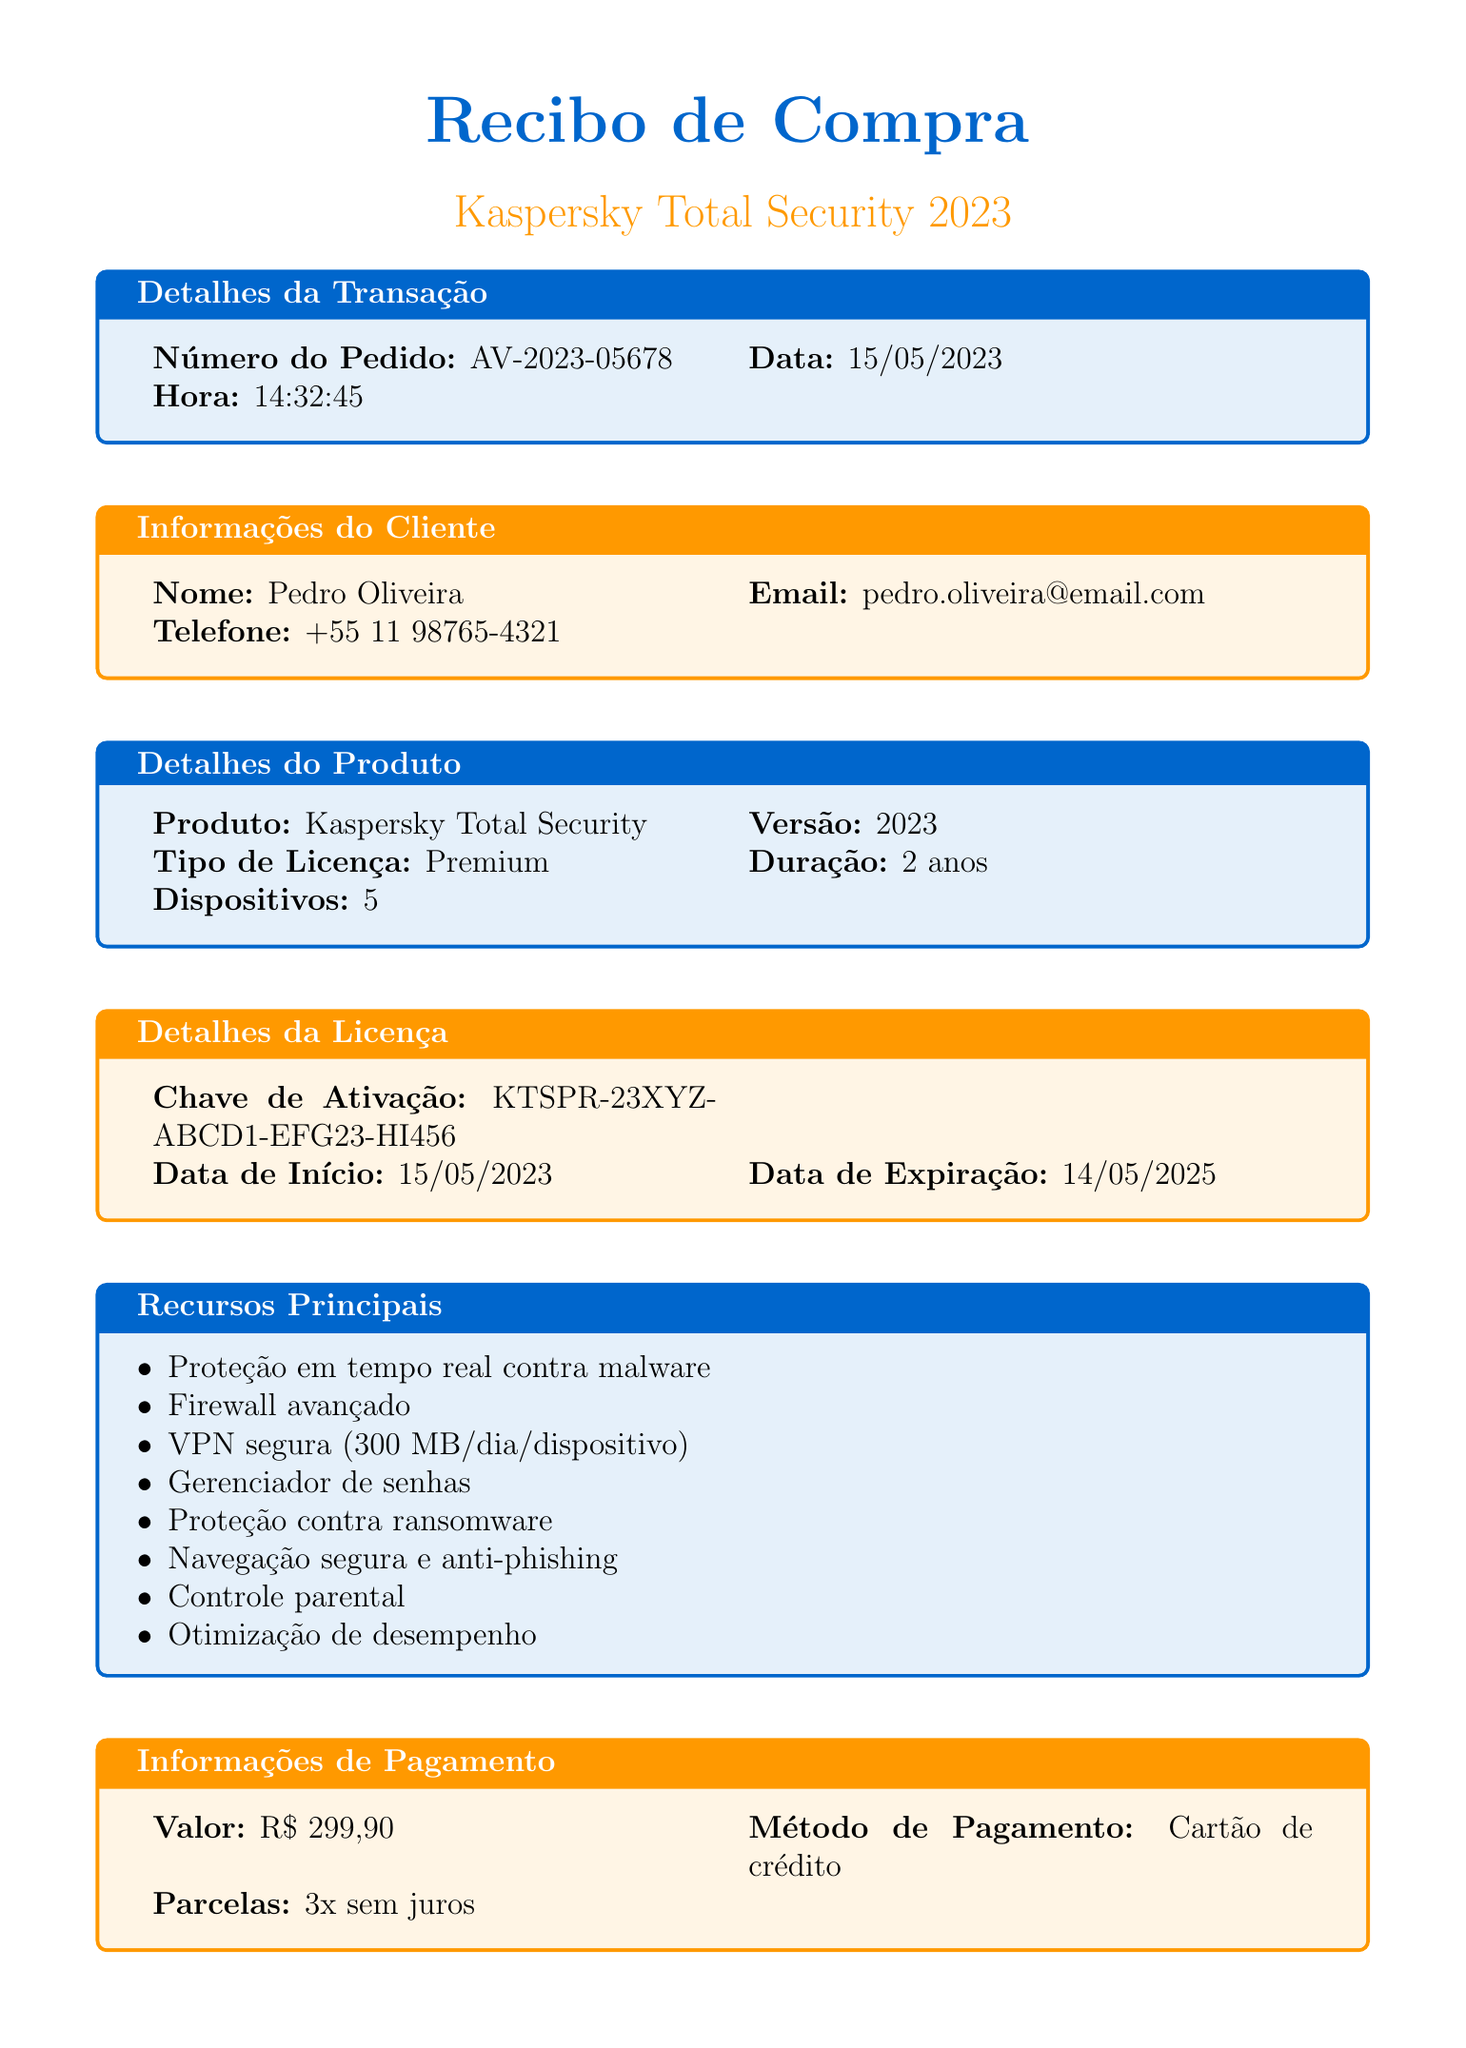Qual é o número do pedido? O número do pedido é uma identificação única da transação, que neste caso é indicado como AV-2023-05678.
Answer: AV-2023-05678 Quando foi realizada a compra? A data da compra está especificada no documento e é 15/05/2023.
Answer: 15/05/2023 Qual é o nome do cliente? O nome do cliente é informado na seção de informações do cliente, que é Pedro Oliveira.
Answer: Pedro Oliveira Qual é a duração da licença adquirida? A duração da licença está indicada como 2 anos.
Answer: 2 anos Quais dispositivos a licença cobre? O documento informa que a licença cobre 5 dispositivos.
Answer: 5 Qual é o valor total da compra? O valor total da compra é mencionado como R$ 299,90.
Answer: R$ 299,90 Qual é a data de expiração da licença? A data de expiração da licença é indicada como 14/05/2025.
Answer: 14/05/2025 Quais são alguns recursos principais do software? A seção de recursos principais lista características como proteção em tempo real contra malware e firewall avançado.
Answer: Proteção em tempo real contra malware, Firewall avançado Quais são as condições para reembolso? As condições para reembolso estão especificadas no documento, sendo reembolso integral se não estiver satisfeito com o produto.
Answer: Reembolso integral se não estiver satisfeito com o produto 